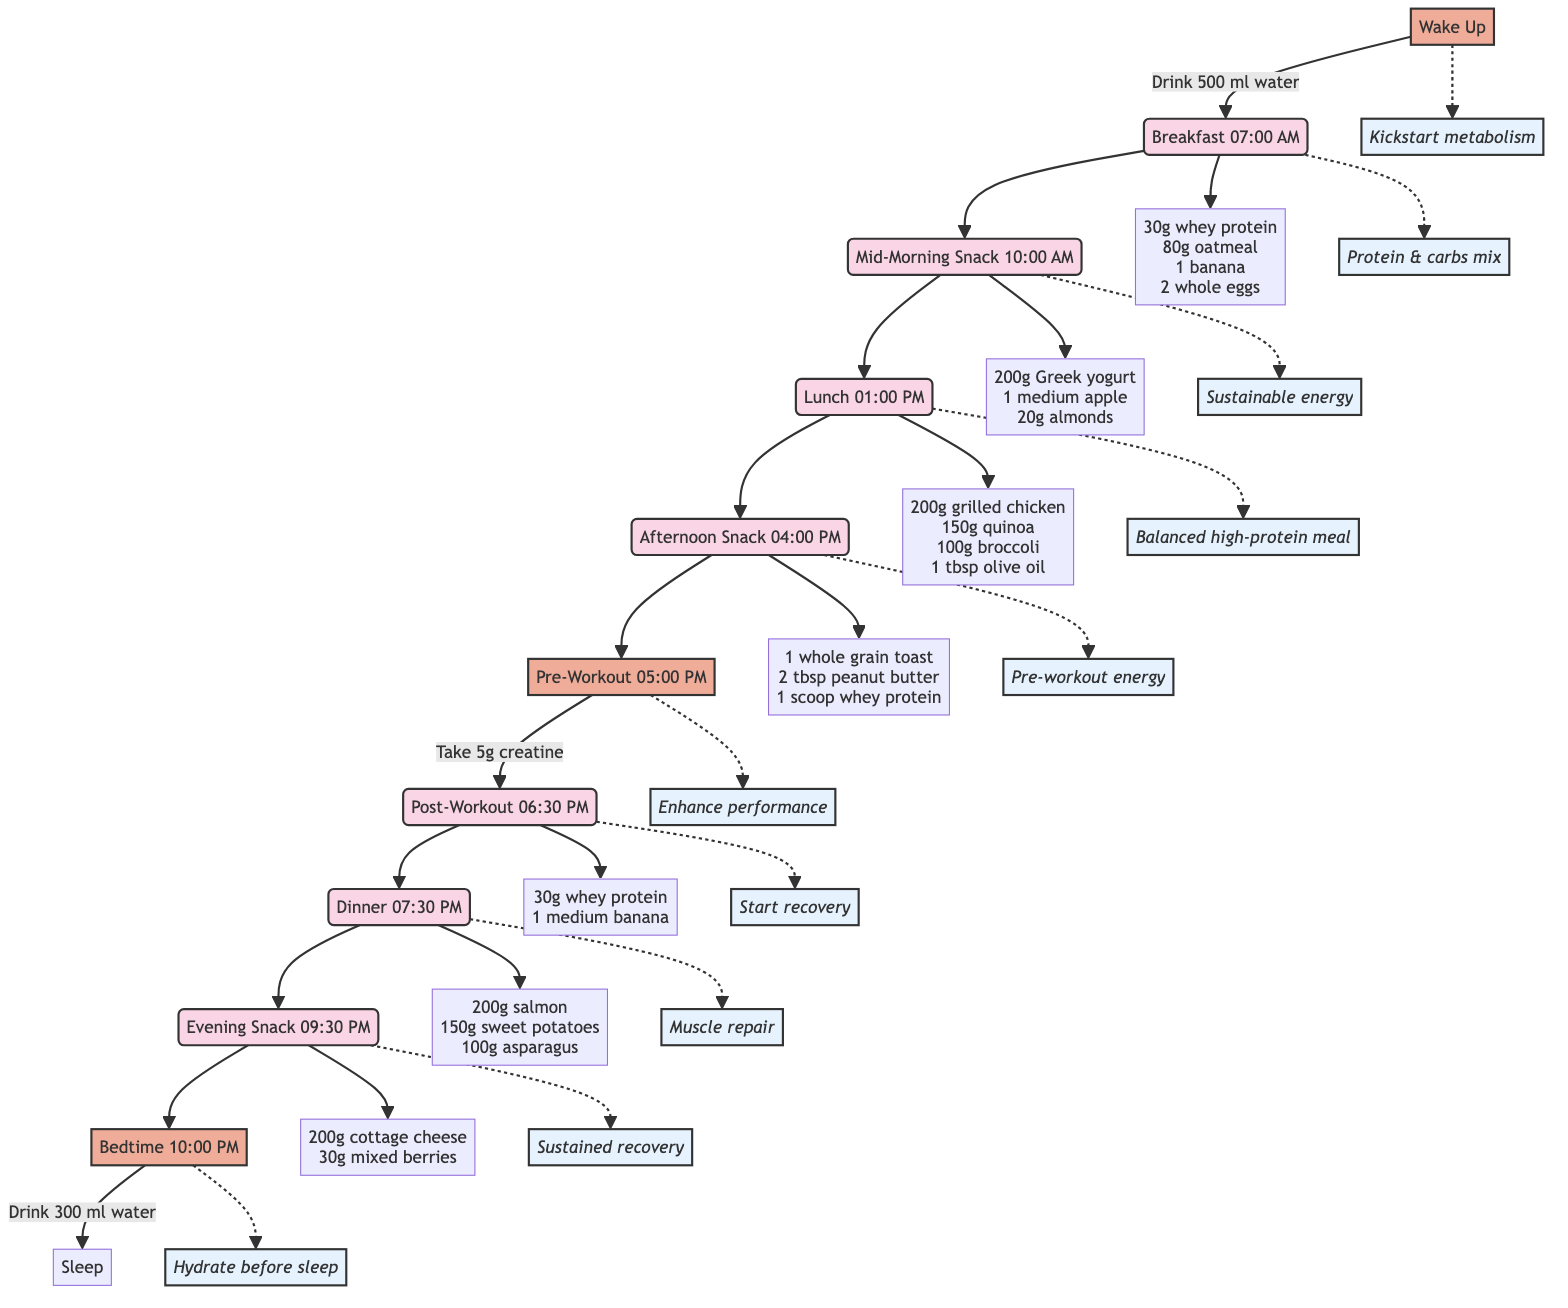What time is breakfast scheduled? Looking at the flowchart, the node labeled "Breakfast" shows that it is scheduled for "07:00 AM".
Answer: 07:00 AM What are the components of the lunch meal? The node for "Lunch" leads to components, which include "200g of grilled chicken breast, 150g of quinoa, 100g of steamed broccoli, 1 tablespoon of olive oil".
Answer: 200g of grilled chicken breast, 150g of quinoa, 100g of steamed broccoli, 1 tablespoon of olive oil How many snacks are listed before bedtime? From the flowchart, I see two snack nodes: "Afternoon Snack" and "Evening Snack", totaling two snacks before "Bedtime".
Answer: 2 What is the main purpose of the pre-workout intake? The "Pre-Workout" node indicates that 5g of creatine monohydrate is taken for "Enhance muscle strength and performance".
Answer: Enhance muscle strength and performance Which meal is indicated as a mix of protein and carbohydrates? The "Breakfast" node connects to the note "Protein & carbs mix," indicating that breakfast has this mixture.
Answer: Breakfast What is consumed at bedtime? The "Bedtime" node shows that 300 ml of water is drunk before sleep.
Answer: 300 ml of water What is the purpose of the post-workout meal? The "Post-Workout" node details that it aims to "Start recovery," which means it facilitates muscle recovery after a workout.
Answer: Start recovery What is the timing of the evening snack? Checking the "Evening Snack" node, it is scheduled for "09:30 PM".
Answer: 09:30 PM 